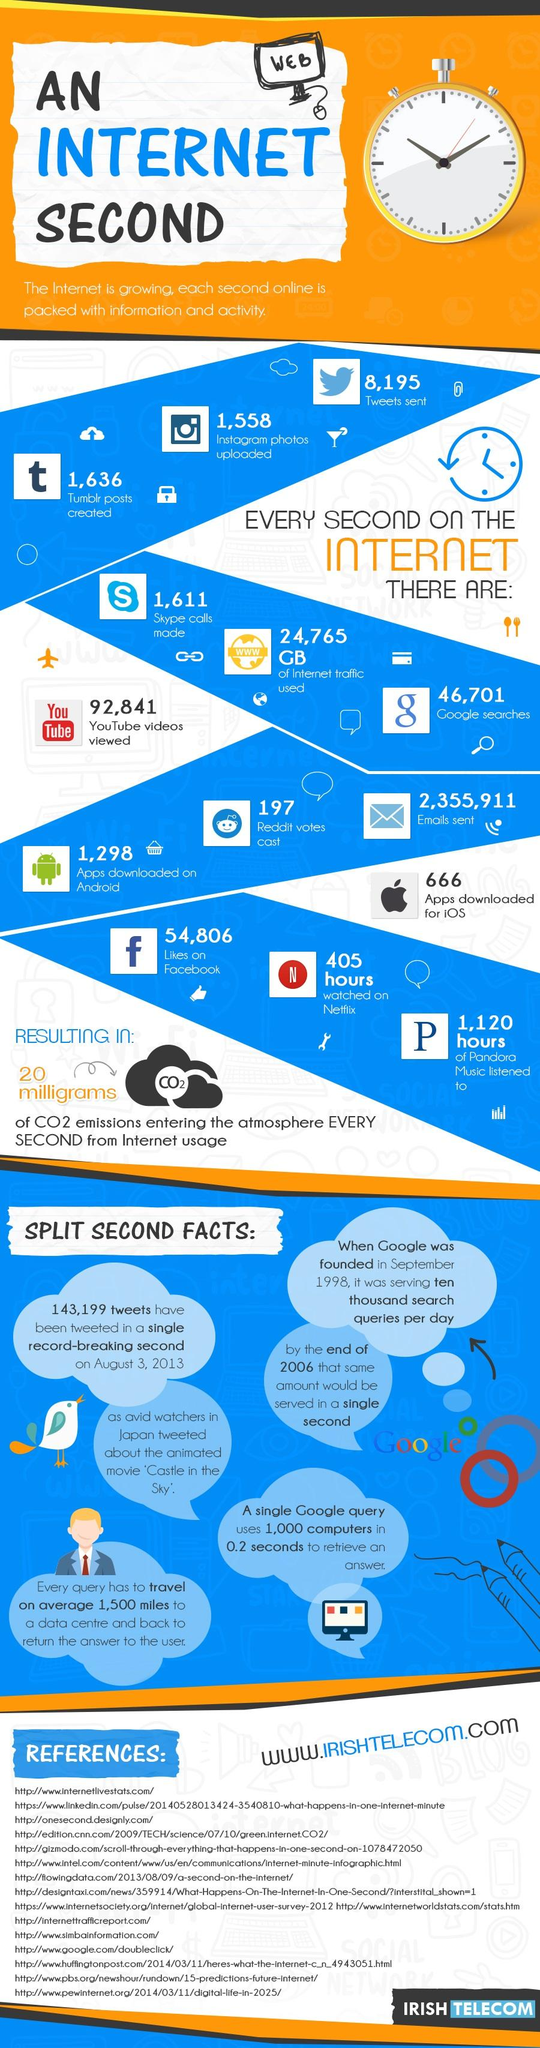Point out several critical features in this image. According to recent data, an average of 92,841 YouTube videos are viewed every second on the internet. It is estimated that approximately 2,355,911 emails are sent every second on the internet. In the second on the internet, an average of 1,298 apps were downloaded on Android. In the year 2021, an average of 1,558 Instagram photos were uploaded onto the internet every second. It is not clear what you are asking. Could you please provide more context or clarification? 